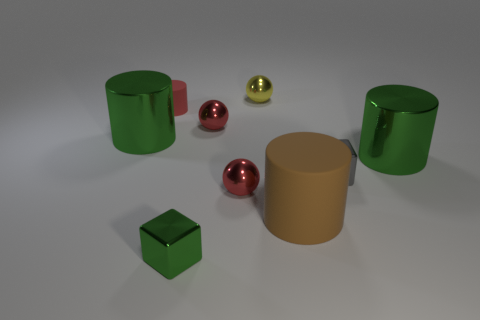The brown matte object is what size?
Offer a very short reply. Large. What is the shape of the brown matte thing?
Keep it short and to the point. Cylinder. What is the tiny cylinder to the left of the matte thing in front of the green cylinder to the right of the gray metal thing made of?
Provide a succinct answer. Rubber. What number of objects are tiny gray metallic cubes or big red matte blocks?
Offer a very short reply. 1. Does the green thing right of the brown cylinder have the same material as the tiny cylinder?
Your response must be concise. No. How many things are red objects in front of the gray metallic cube or yellow balls?
Offer a terse response. 2. What color is the object that is the same material as the brown cylinder?
Offer a very short reply. Red. Are there any red metallic things that have the same size as the yellow metallic object?
Offer a very short reply. Yes. There is a sphere in front of the tiny gray metal thing; is its color the same as the tiny matte cylinder?
Provide a succinct answer. Yes. What color is the cylinder that is both in front of the tiny red cylinder and to the left of the brown cylinder?
Make the answer very short. Green. 